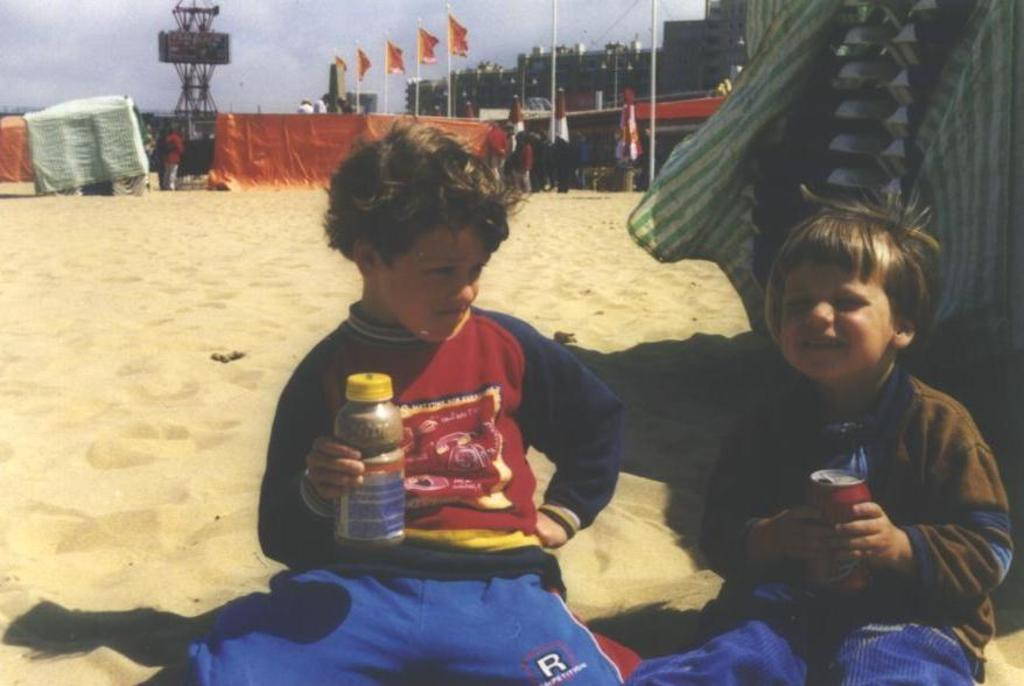How many boys are in the image? There are two boys in the image. What are the boys holding in their hands? The boys are holding bottles and tins. What type of surface are the boys sitting on? The boys are sitting on a sand floor. What can be seen in the background of the image? There are flags and buildings visible in the background. Are there any geese playing chess with the boys in the image? There are no geese or chess present in the image. What type of party is being held in the background of the image? There is no party visible in the image; only flags and buildings can be seen in the background. 